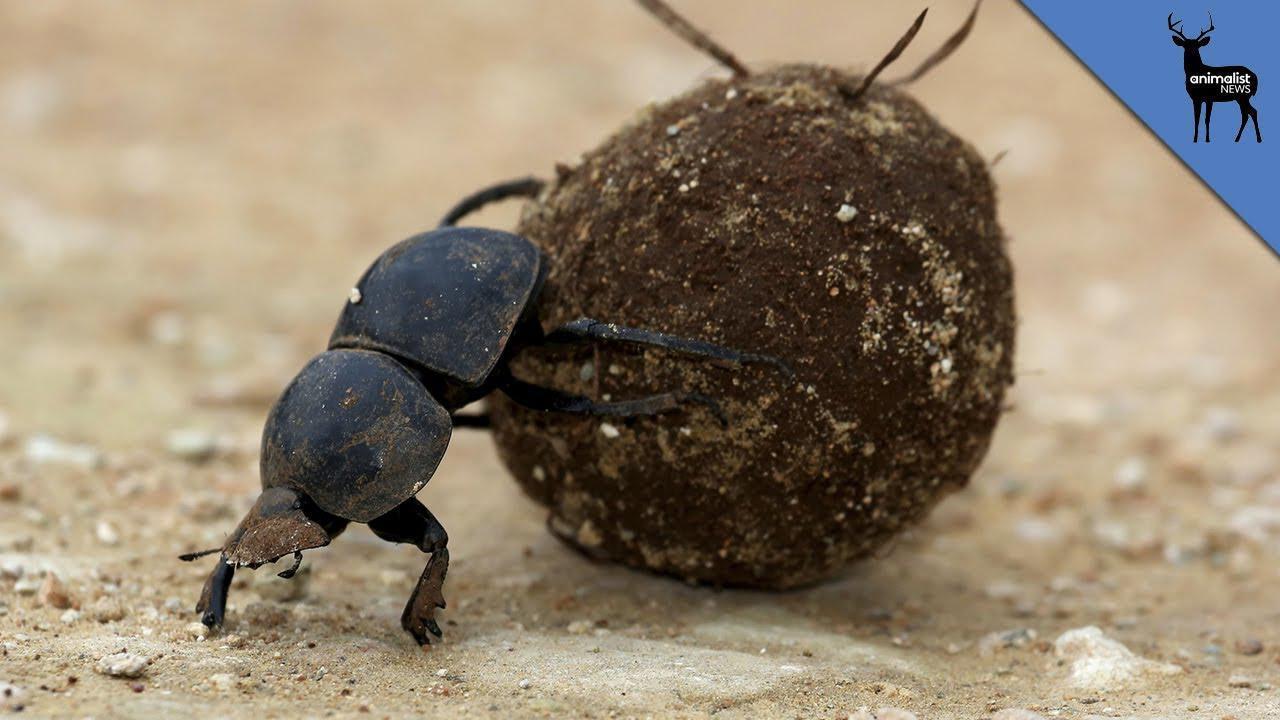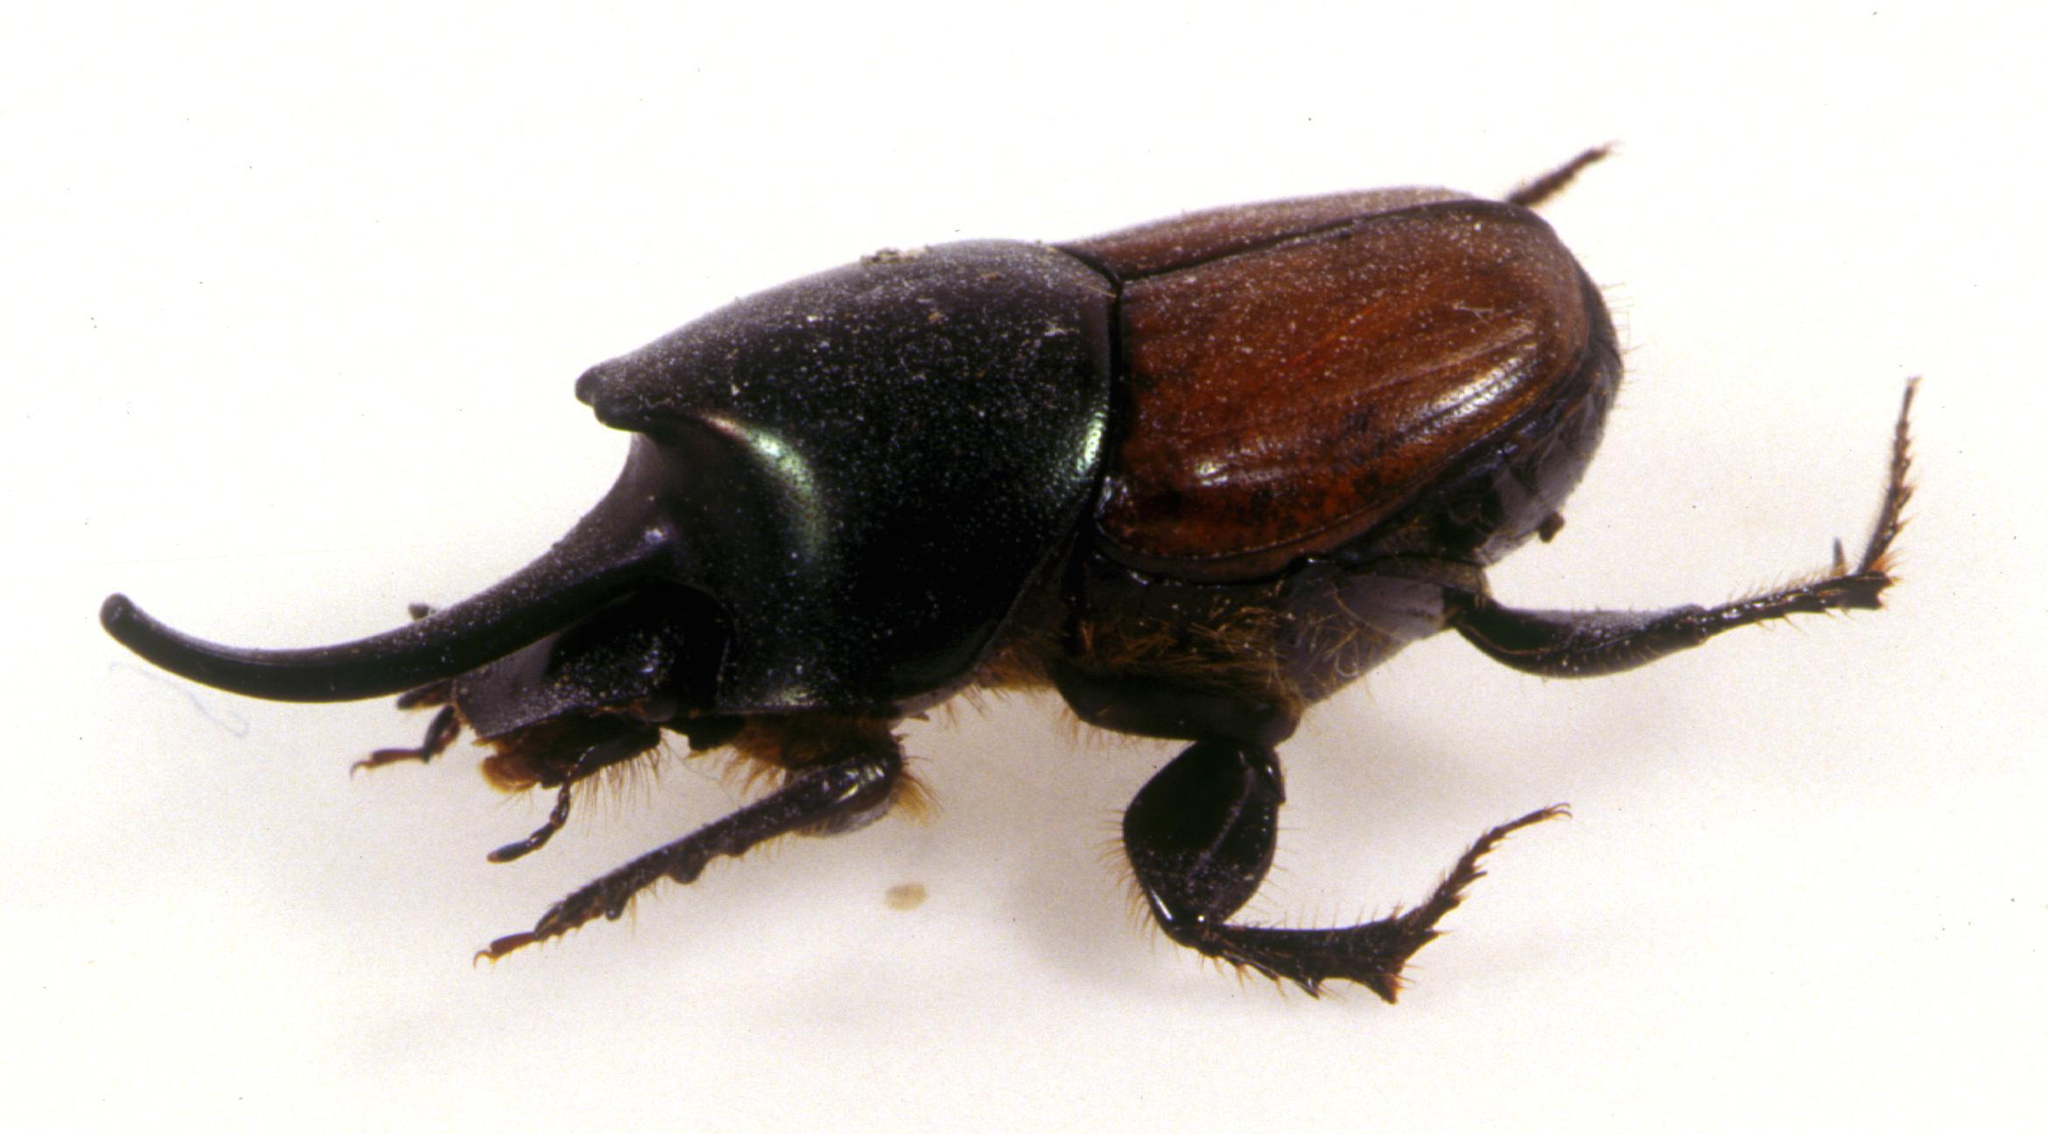The first image is the image on the left, the second image is the image on the right. Given the left and right images, does the statement "There is a beetle on top of a dung ball." hold true? Answer yes or no. No. The first image is the image on the left, the second image is the image on the right. Given the left and right images, does the statement "Each image shows a beetle with a dungball that is bigger than the beetle." hold true? Answer yes or no. No. 